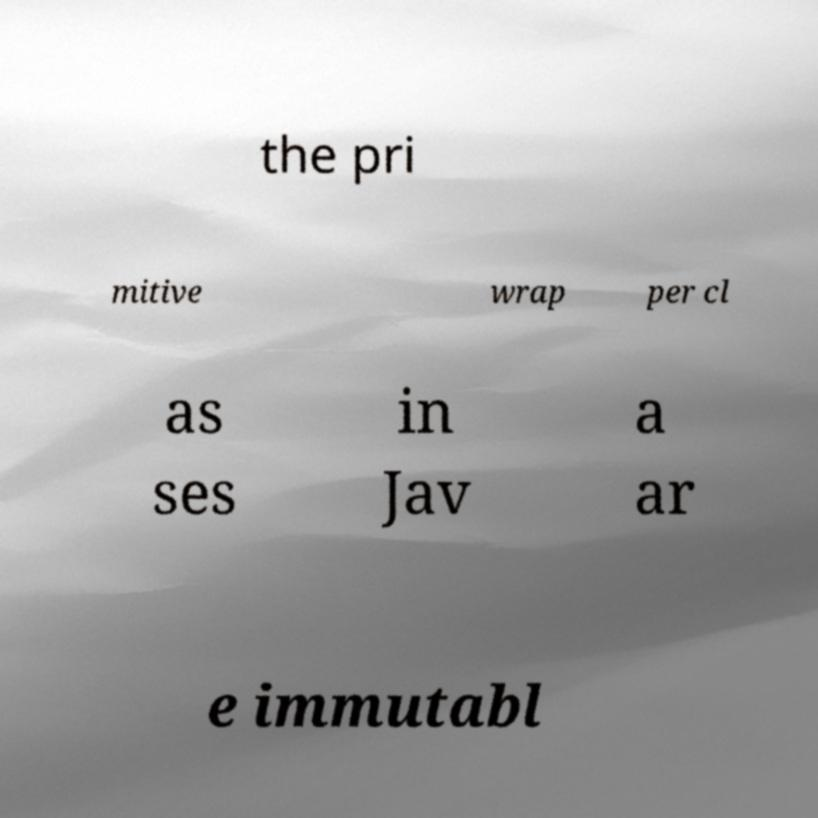Can you accurately transcribe the text from the provided image for me? the pri mitive wrap per cl as ses in Jav a ar e immutabl 